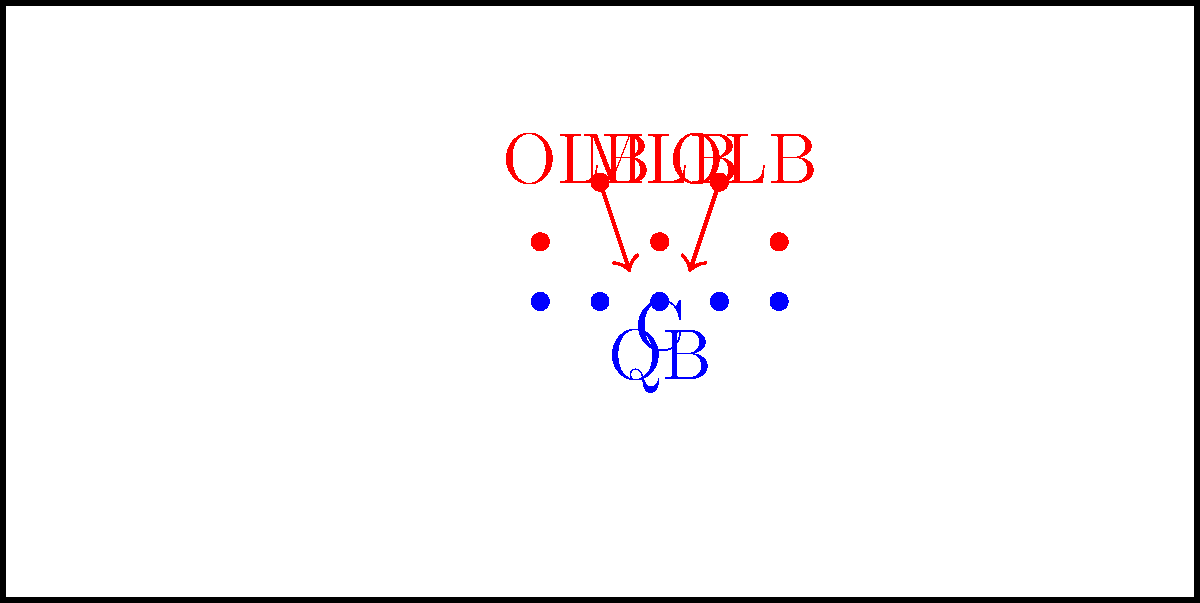In the diagram above, the defense is showing a potential blitz package. As the offensive line coach, what pass protection scheme would you recommend to best counter this defensive formation, and why? To answer this question, let's analyze the defensive formation and consider our options:

1. Defensive alignment:
   - 3 down linemen (red dots on the line of scrimmage)
   - 2 outside linebackers (OLB) and 1 middle linebacker (MLB) showing blitz

2. Potential threats:
   - Both OLBs are in position to blitz
   - The MLB is also in a position to blitz or drop into coverage

3. Pass protection options:
   a) Man-to-man protection: Each offensive lineman is responsible for a specific defender
   b) Zone protection: Linemen work together to protect areas rather than specific defenders
   c) Slide protection: The line "slides" in one direction, with a back responsible for the backside

4. Recommended scheme: Slide protection with running back help

5. Reasoning:
   - Slide protection allows the offensive line to shift towards the side with more potential blitzers
   - In this case, slide to the right (strong side) to account for the OLB and down lineman
   - The left tackle can pick up the weak side OLB
   - The running back can be responsible for the MLB if he blitzes or help on the weak side if needed

6. Implementation:
   - Center, right guard, and right tackle slide right
   - Left guard helps center before moving to second level
   - Left tackle takes on weak side OLB
   - Running back reads MLB and helps on weak side if needed

This scheme provides flexibility to handle multiple blitz scenarios while maintaining solid protection for the quarterback.
Answer: Slide protection with running back help 